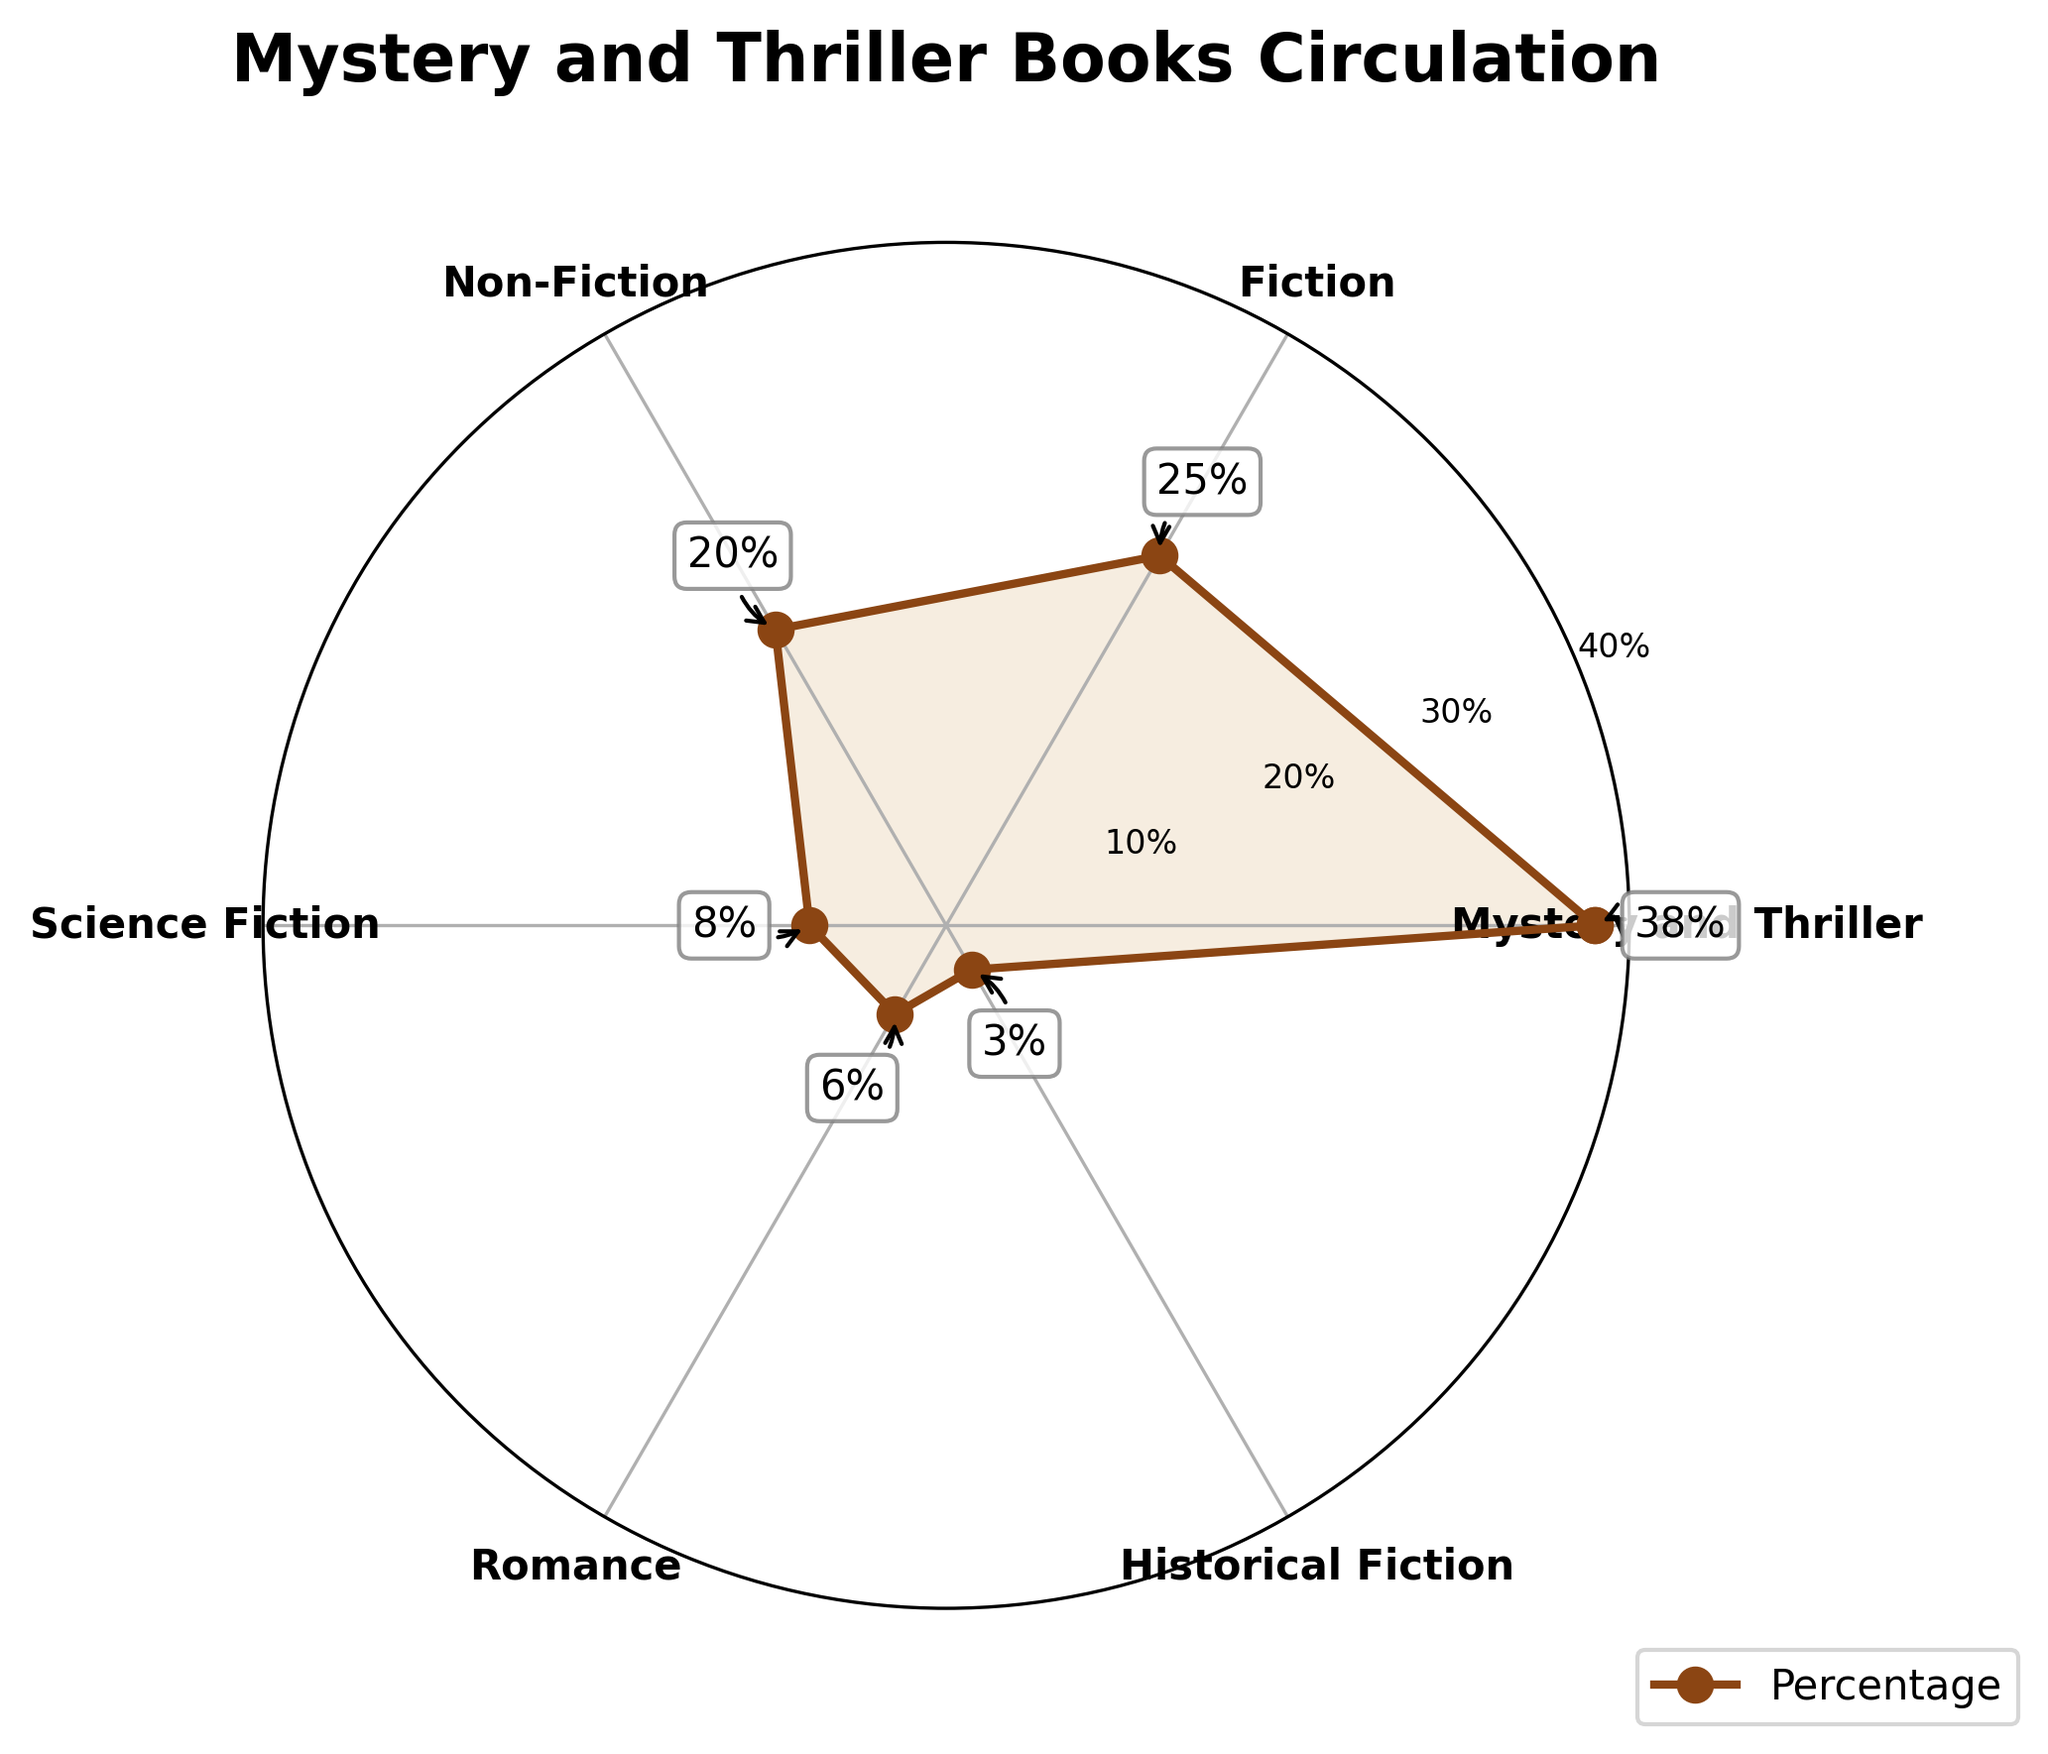What's the title of the plot? The title is usually located at the top of the plot and provides a summary of the information being visualized. In this plot, it reads "Mystery and Thriller Books Circulation".
Answer: Mystery and Thriller Books Circulation How many genres are represented in the plot? To determine the number of genres, count the labels around the polar plot. There are labels for Mystery and Thriller, Fiction, Non-Fiction, Science Fiction, Romance, and Historical Fiction.
Answer: 6 What genre has the highest percentage of books in circulation? By observing the plot, identify the genre with the highest value on the y-axis. The segment labeled "Mystery and Thriller" reaches the furthest at 38%.
Answer: Mystery and Thriller Which two genres have the smallest percentages? Look for the genres with the smallest radial lengths. Historical Fiction at 3% and Romance at 6% are the smallest.
Answer: Historical Fiction and Romance What's the total percentage of Fiction and Non-Fiction books? Add the percentages for Fiction (25%) and Non-Fiction (20%) together: 25% + 20% = 45%.
Answer: 45% Compare the percentage of Mystery and Thriller books to Science Fiction books. What's the difference? Subtract the percentage for Science Fiction (8%) from the percentage for Mystery and Thriller (38%): 38% - 8% = 30%.
Answer: 30% What percentage of genres have more books in circulation than Science Fiction? Identifying genres with percentages greater than 8% (Science Fiction) are: Mystery and Thriller (38%), Fiction (25%), and Non-Fiction (20%). Three out of six genres meet this criteria, equating to 50%.
Answer: 50% What is the average percentage of all genres? Sum the total percentages (38 + 25 + 20 + 8 + 6 + 3 = 100) and divide by the number of genres (6): 100/6 ≈ 16.7%.
Answer: 16.7% What is the combined percentage of genres other than Mystery and Thriller? Adding up the percentages of all other genres: Fiction (25%) + Non-Fiction (20%) + Science Fiction (8%) + Romance (6%) + Historical Fiction (3%) = 62%.
Answer: 62% What visual element represents the highest percentage in the polar plot? The annotation callout on the Mystery and Thriller segment points to the highest percentage of 38%. It is marked by an arrow and annotated with 38%.
Answer: 38% 